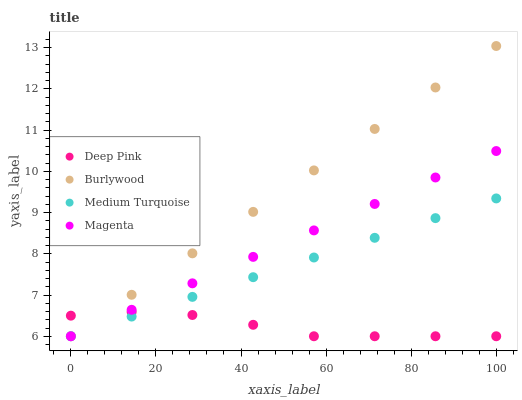Does Deep Pink have the minimum area under the curve?
Answer yes or no. Yes. Does Burlywood have the maximum area under the curve?
Answer yes or no. Yes. Does Magenta have the minimum area under the curve?
Answer yes or no. No. Does Magenta have the maximum area under the curve?
Answer yes or no. No. Is Magenta the smoothest?
Answer yes or no. Yes. Is Deep Pink the roughest?
Answer yes or no. Yes. Is Deep Pink the smoothest?
Answer yes or no. No. Is Magenta the roughest?
Answer yes or no. No. Does Burlywood have the lowest value?
Answer yes or no. Yes. Does Burlywood have the highest value?
Answer yes or no. Yes. Does Magenta have the highest value?
Answer yes or no. No. Does Deep Pink intersect Medium Turquoise?
Answer yes or no. Yes. Is Deep Pink less than Medium Turquoise?
Answer yes or no. No. Is Deep Pink greater than Medium Turquoise?
Answer yes or no. No. 